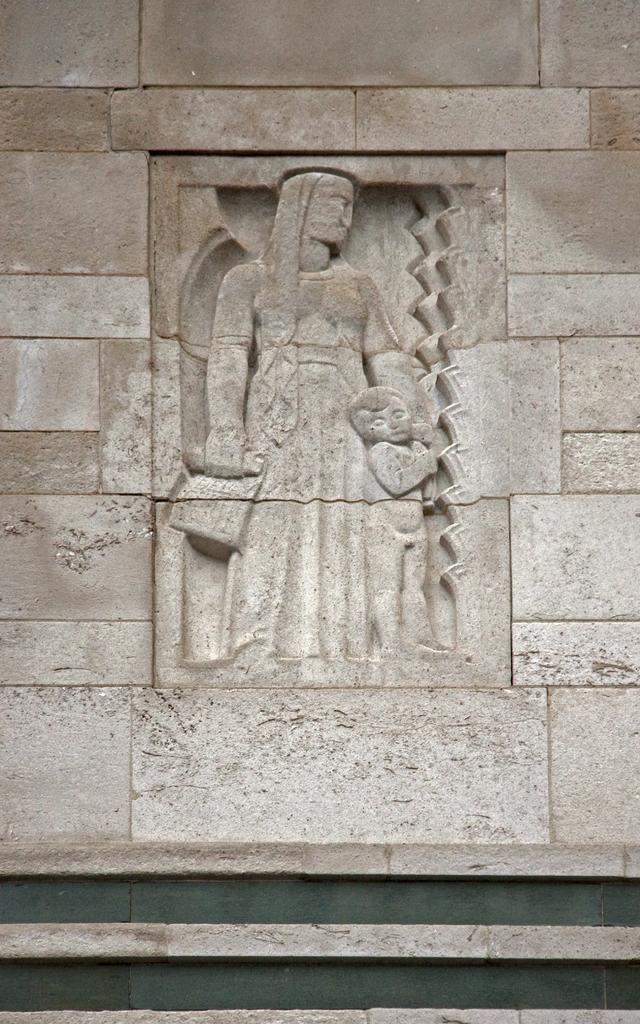What type of structure is present in the image? There is a wall in the image. What can be seen on the wall? The wall has sculptures of a person and a kid. What are the positions of the person and kid sculptures on the wall? The person and kid sculptures are standing. How many beds are visible in the image? There are no beds present in the image; it features a wall with sculptures of a person and a kid. What type of cake is being served in the image? There is no cake present in the image. 